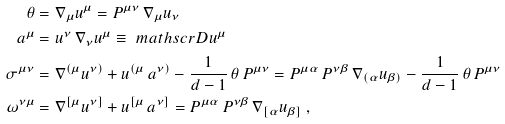<formula> <loc_0><loc_0><loc_500><loc_500>\theta & = \nabla _ { \mu } u ^ { \mu } = P ^ { \mu \nu } \, \nabla _ { \mu } u _ { \nu } \\ a ^ { \mu } & = u ^ { \nu } \, \nabla _ { \nu } u ^ { \mu } \equiv \ m a t h s c r D u ^ { \mu } \\ \sigma ^ { \mu \nu } & = \nabla ^ { ( \mu } u ^ { \nu ) } + u ^ { ( \mu } \, a ^ { \nu ) } - \frac { 1 } { d - 1 } \, \theta \, P ^ { \mu \nu } = P ^ { \mu \alpha } \, P ^ { \nu \beta } \, \nabla _ { ( \alpha } u _ { \beta ) } - \frac { 1 } { d - 1 } \, \theta \, P ^ { \mu \nu } \\ \omega ^ { \nu \mu } & = \nabla ^ { [ \mu } u ^ { \nu ] } + u ^ { [ \mu } \, a ^ { \nu ] } = P ^ { \mu \alpha } \, P ^ { \nu \beta } \, \nabla _ { [ \alpha } u _ { \beta ] } \ ,</formula> 